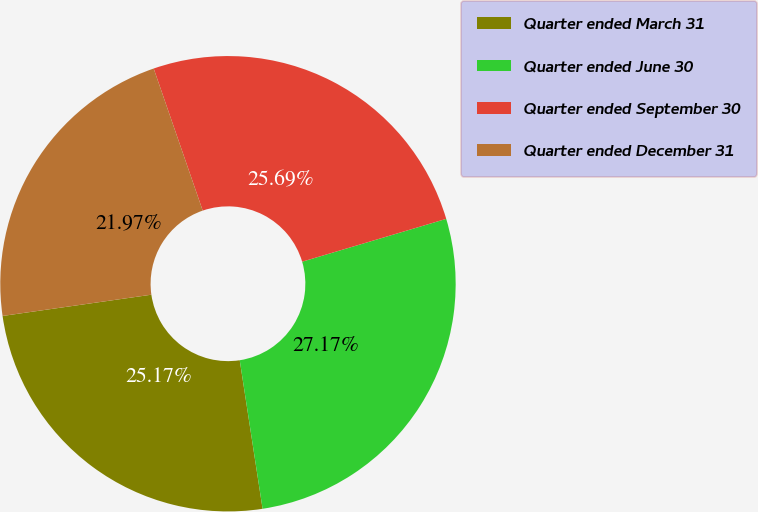Convert chart to OTSL. <chart><loc_0><loc_0><loc_500><loc_500><pie_chart><fcel>Quarter ended March 31<fcel>Quarter ended June 30<fcel>Quarter ended September 30<fcel>Quarter ended December 31<nl><fcel>25.17%<fcel>27.17%<fcel>25.69%<fcel>21.97%<nl></chart> 